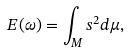Convert formula to latex. <formula><loc_0><loc_0><loc_500><loc_500>E ( \omega ) = \int _ { M } s ^ { 2 } d \mu ,</formula> 